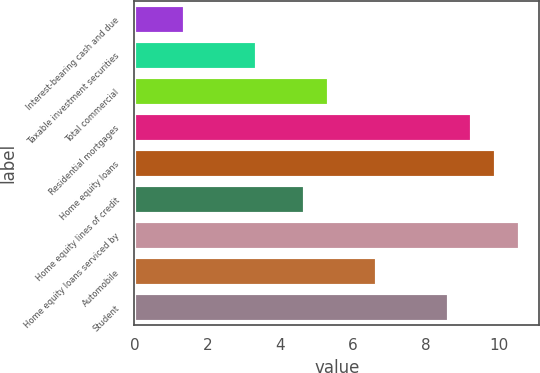Convert chart to OTSL. <chart><loc_0><loc_0><loc_500><loc_500><bar_chart><fcel>Interest-bearing cash and due<fcel>Taxable investment securities<fcel>Total commercial<fcel>Residential mortgages<fcel>Home equity loans<fcel>Home equity lines of credit<fcel>Home equity loans serviced by<fcel>Automobile<fcel>Student<nl><fcel>1.39<fcel>3.36<fcel>5.33<fcel>9.27<fcel>9.92<fcel>4.67<fcel>10.57<fcel>6.65<fcel>8.62<nl></chart> 